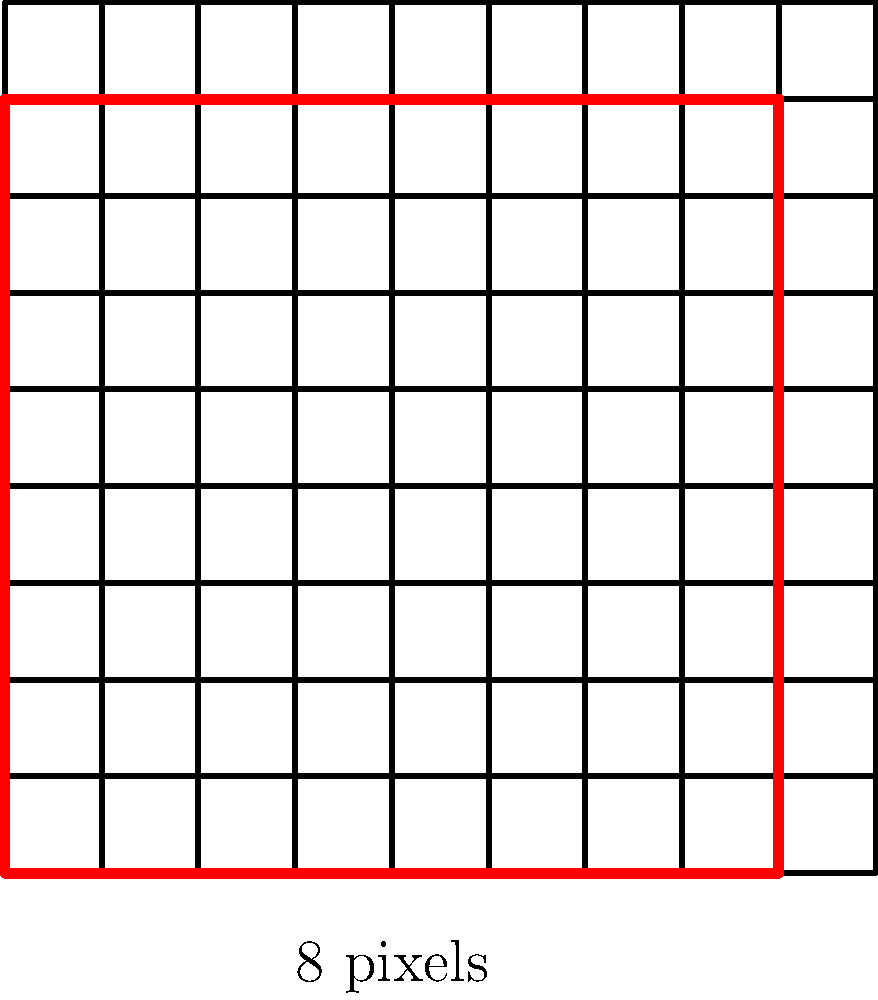You're designing a pixel art frame for a collaborative project. The frame is currently 8x8 pixels. If you want to maximize the area-to-perimeter ratio while keeping the total number of pixels in the frame between 60 and 70, what should be the new dimensions of the frame? Let's approach this step-by-step:

1) The area-to-perimeter ratio for a rectangle is given by:
   $$\frac{A}{P} = \frac{lw}{2(l+w)}$$
   where $l$ is length and $w$ is width.

2) For a square, where $l = w$, this ratio is maximized. So, we should aim for a square shape.

3) The total number of pixels should be between 60 and 70. The perfect square in this range is 64 (8x8).

4) Let's verify the area-to-perimeter ratio for an 8x8 frame:
   $$\frac{A}{P} = \frac{8 \times 8}{2(8+8)} = \frac{64}{32} = 2$$

5) The next perfect square is 81 (9x9), which is outside our range.

6) The only other option to consider is 7x9 = 63 pixels, which is within our range.
   Let's calculate its area-to-perimeter ratio:
   $$\frac{A}{P} = \frac{7 \times 9}{2(7+9)} = \frac{63}{32} = 1.96875$$

7) The 8x8 frame has a higher area-to-perimeter ratio (2 > 1.96875) and fits within our pixel range.

Therefore, the optimal dimensions to maximize the area-to-perimeter ratio while keeping the total pixels between 60 and 70 is 8x8 pixels.
Answer: 8x8 pixels 